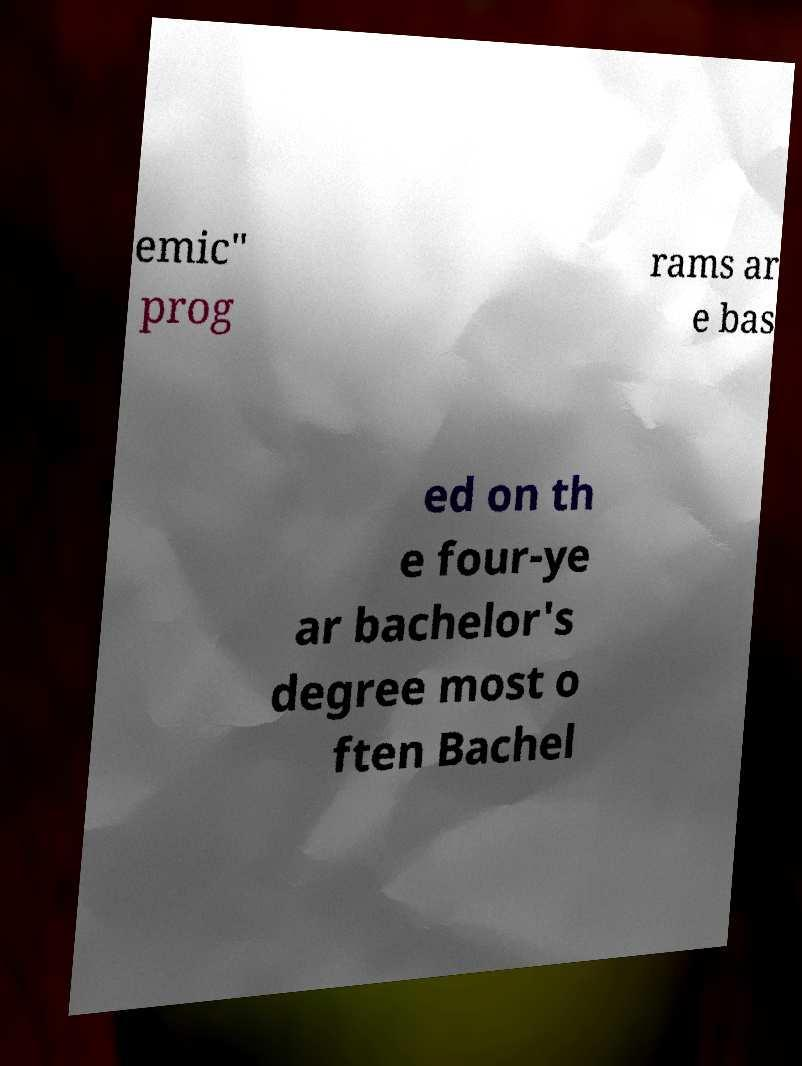Could you assist in decoding the text presented in this image and type it out clearly? emic" prog rams ar e bas ed on th e four-ye ar bachelor's degree most o ften Bachel 